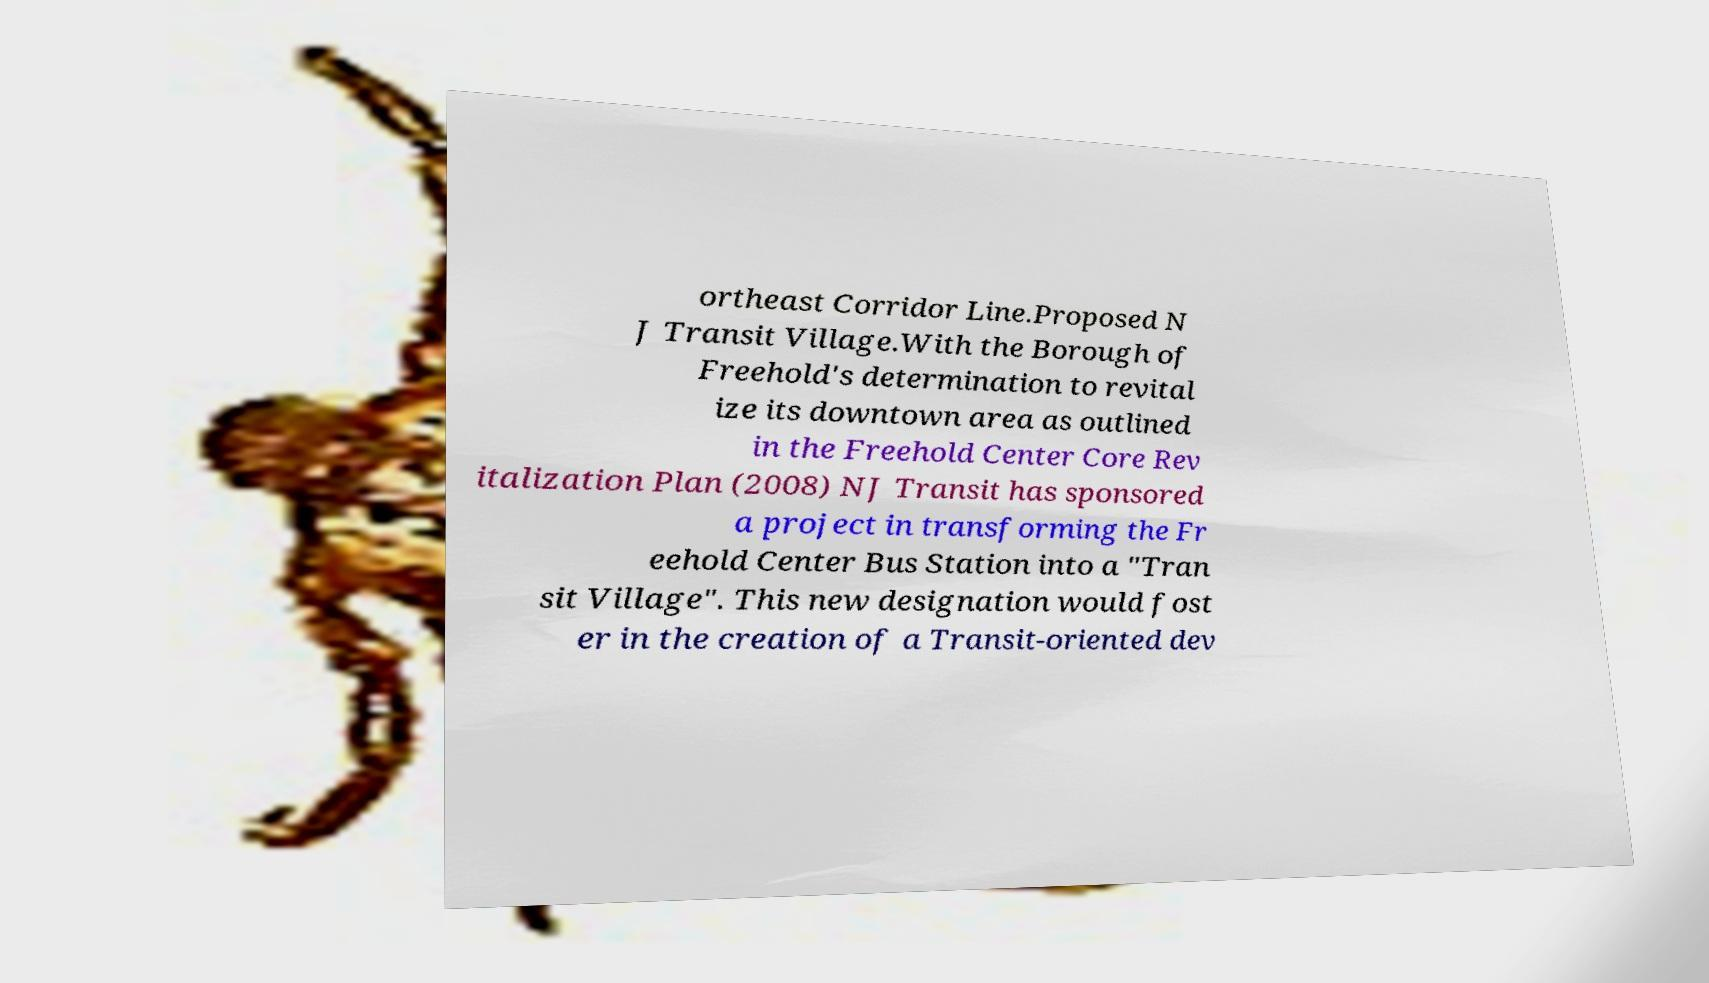What messages or text are displayed in this image? I need them in a readable, typed format. ortheast Corridor Line.Proposed N J Transit Village.With the Borough of Freehold's determination to revital ize its downtown area as outlined in the Freehold Center Core Rev italization Plan (2008) NJ Transit has sponsored a project in transforming the Fr eehold Center Bus Station into a "Tran sit Village". This new designation would fost er in the creation of a Transit-oriented dev 